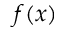Convert formula to latex. <formula><loc_0><loc_0><loc_500><loc_500>f ( x )</formula> 